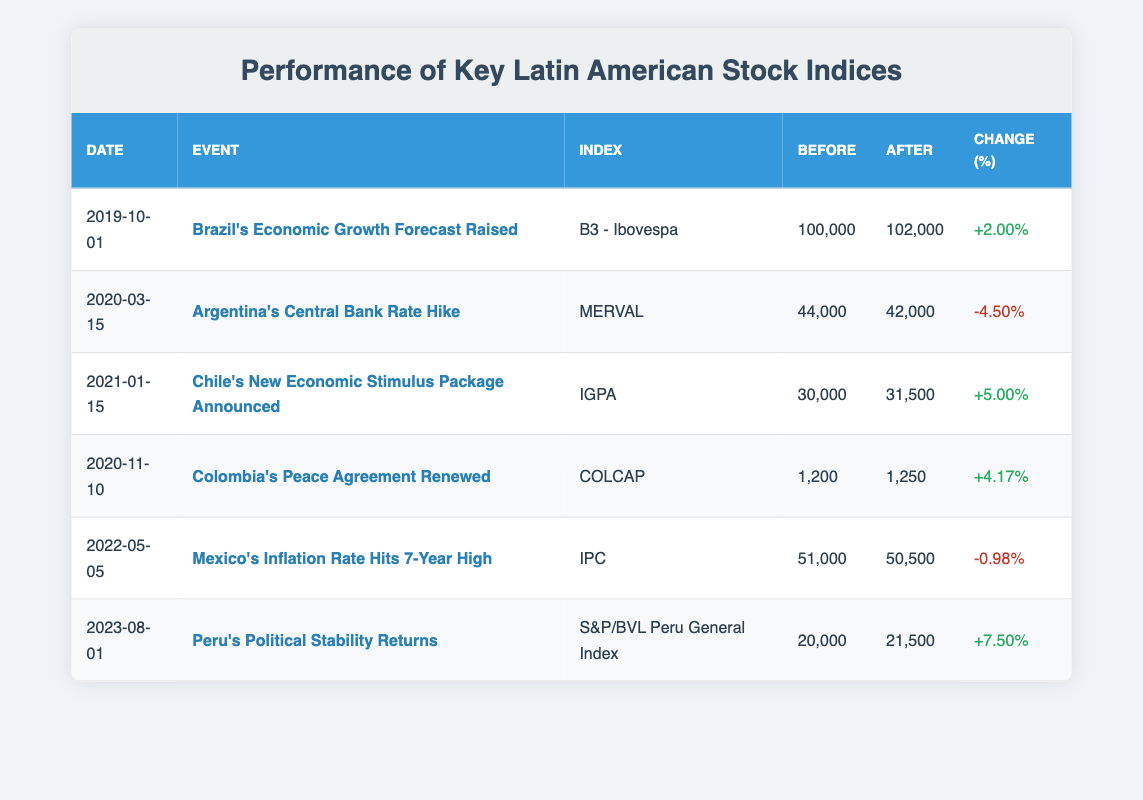What was the percentage change in the B3 - Ibovespa index after Brazil's Economic Growth Forecast was raised? The B3 - Ibovespa index experienced a percentage change of +2.00% after the event on 2019-10-01. This value is directly stated in the table under the percentage change column for this specific event.
Answer: +2.00% What event caused a decrease in the MERVAL index? The MERVAL index decreased after Argentina's Central Bank raised the rate on 2020-03-15, which is indicated by the negative percentage change of -4.50%. This is found in the row corresponding to that date and event in the table.
Answer: Argentina's Central Bank Rate Hike Which index had the highest percentage increase? To find the highest percentage increase, we can observe the percentage changes for each index. The S&P/BVL Peru General Index had the highest percentage increase of +7.50% after Peru's Political Stability returned on 2023-08-01. This is the maximum value listed in the percentage change column across all rows.
Answer: S&P/BVL Peru General Index (+7.50%) Was there any event where the index value after the event was lower than before? Yes, the event on 2020-03-15 concerning Argentina's Central Bank Rate Hike resulted in the MERVAL index dropping from 44,000 to 42,000, represented by a negative percentage change of -4.50%. This confirms that the index value after the event was indeed lower than before.
Answer: Yes What is the average percentage change across all events listed in the table? To find the average percentage change, we sum the percentage changes: 2.00% + (-4.50%) + 5.00% + 4.17% + (-0.98%) + 7.50%. This totals to 13.19%. There are 6 events, so dividing 13.19% by 6 gives us an average of approximately +2.20%.
Answer: +2.20% 